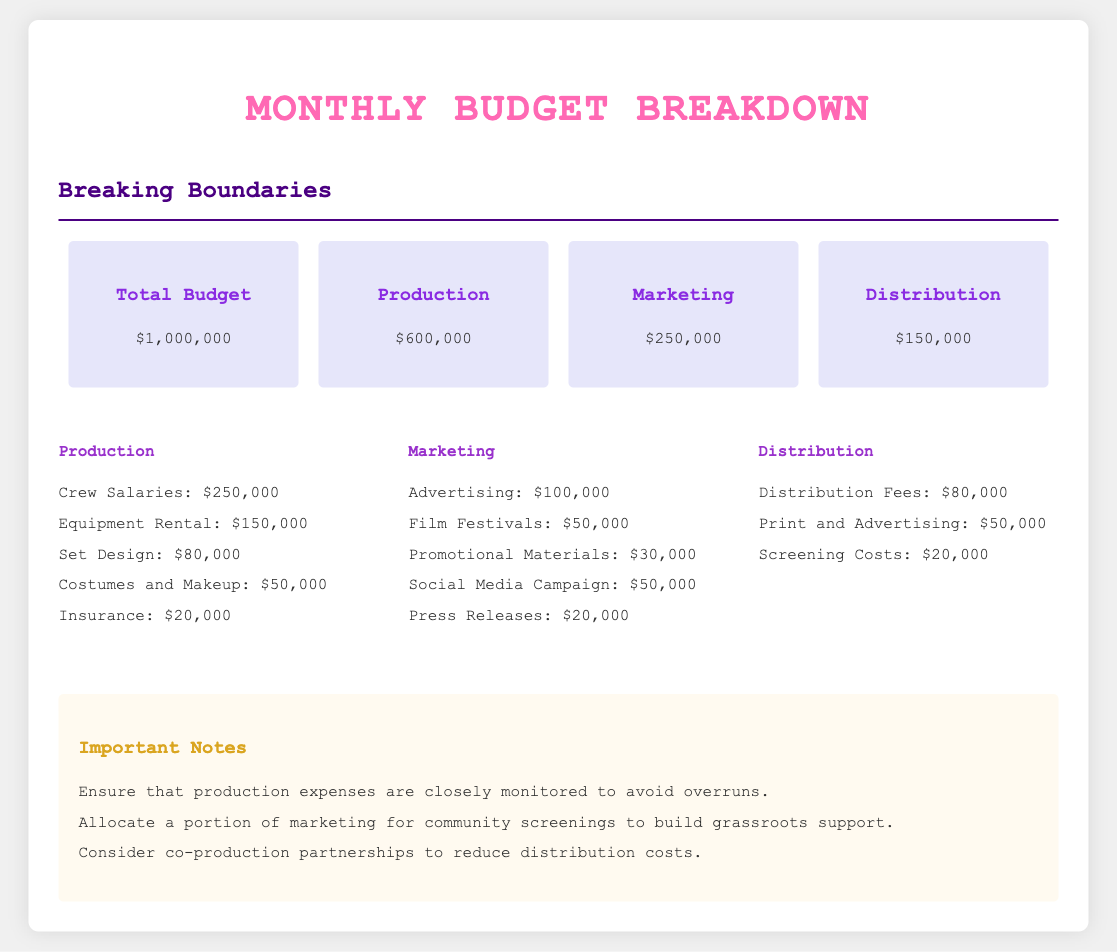What is the total budget? The total budget is clearly stated in the document as $1,000,000.
Answer: $1,000,000 How much is allocated for production? The production allocation is specified as $600,000 within the budget overview section.
Answer: $600,000 What is the budget for marketing? The budget for marketing is provided as $250,000 in the document.
Answer: $250,000 How much will be spent on distribution? The document indicates that the distribution budget is $150,000.
Answer: $150,000 What percentage of the budget is for crew salaries? Crew salaries are listed as $250,000, which is 25% of the total budget of $1,000,000.
Answer: 25% What is the least expensive production item? The least expensive production item is insurance, which costs $20,000.
Answer: $20,000 How much is allocated for advertising in marketing? The advertising budget in marketing is specified as $100,000.
Answer: $100,000 What total amount is earmarked for print and advertising in distribution? The total allocated for print and advertising is $50,000.
Answer: $50,000 What is one important note regarding production expenses? One important note is to ensure that production expenses are closely monitored to avoid overruns.
Answer: Monitor production expenses 